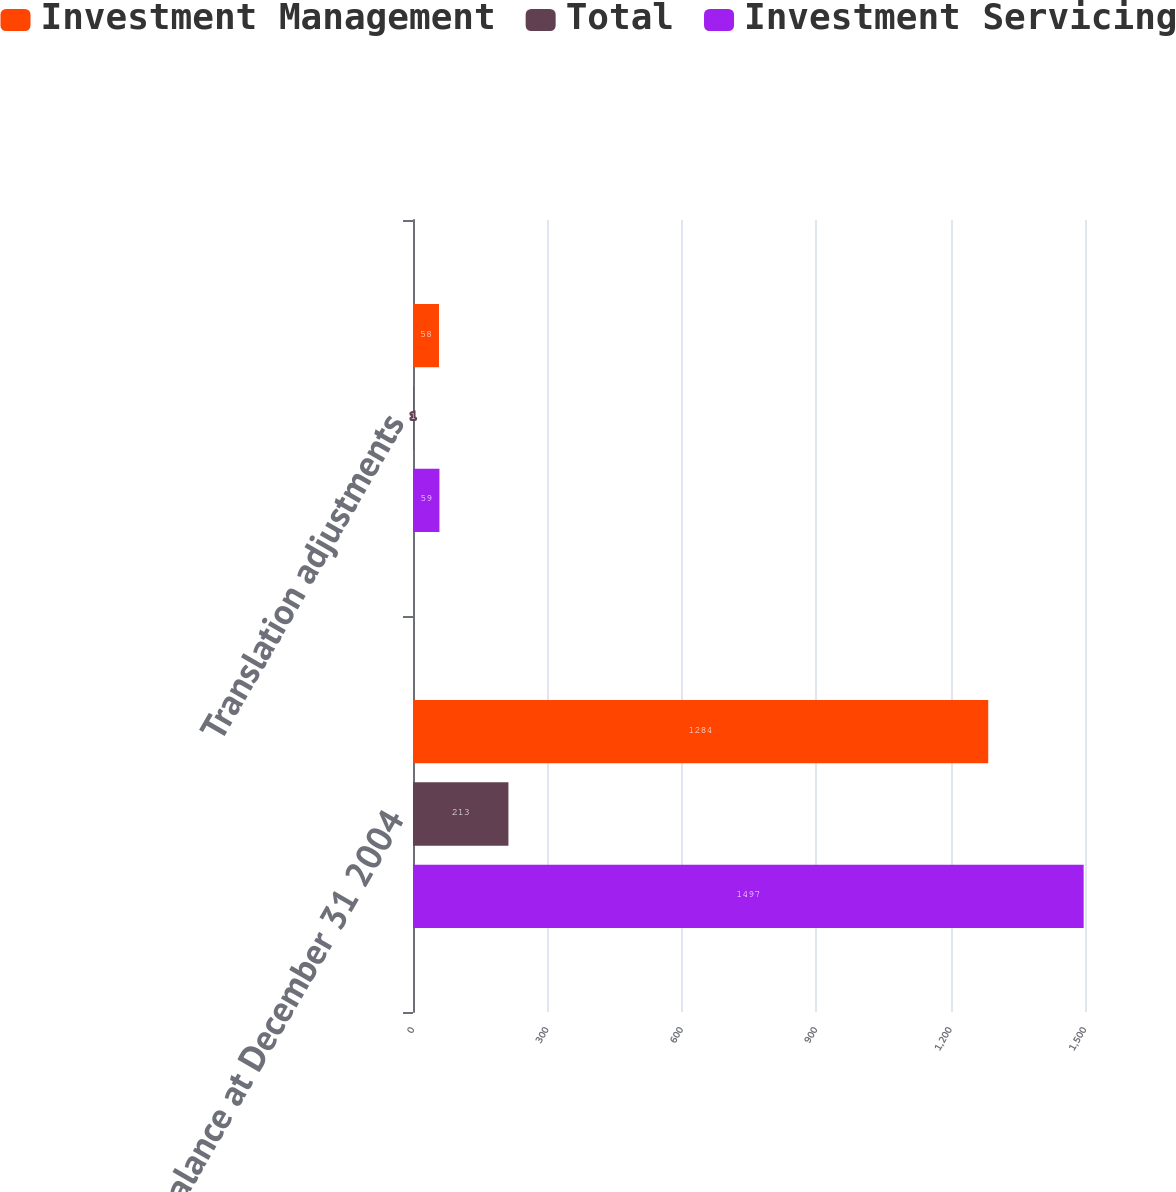<chart> <loc_0><loc_0><loc_500><loc_500><stacked_bar_chart><ecel><fcel>Balance at December 31 2004<fcel>Translation adjustments<nl><fcel>Investment Management<fcel>1284<fcel>58<nl><fcel>Total<fcel>213<fcel>1<nl><fcel>Investment Servicing<fcel>1497<fcel>59<nl></chart> 